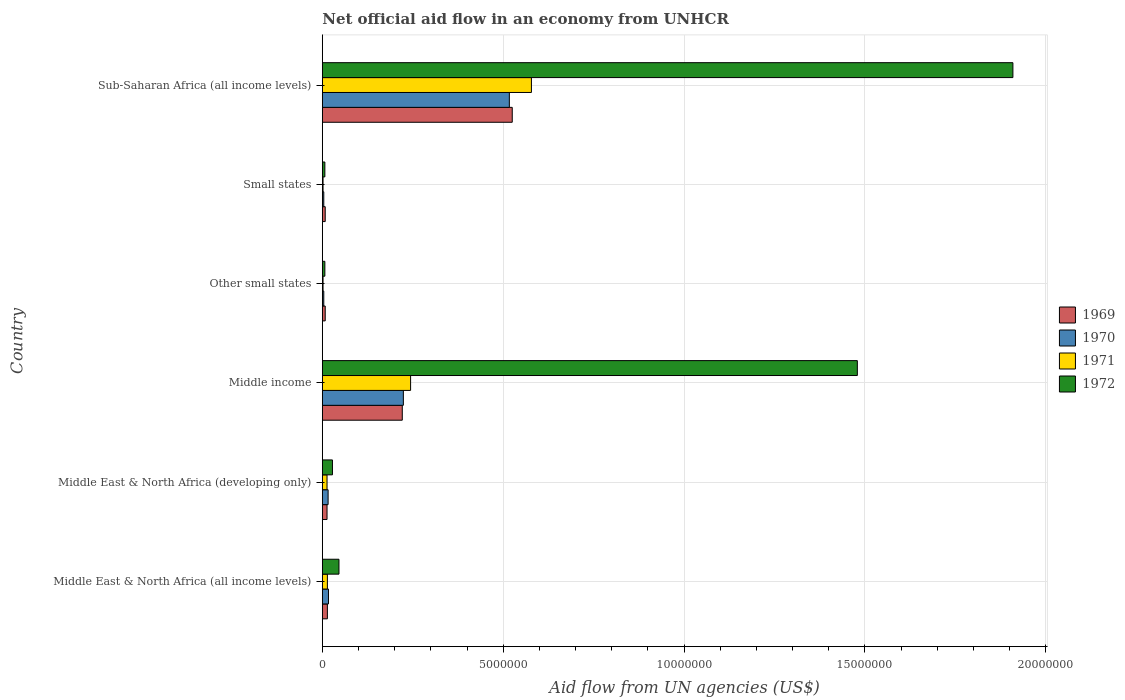How many different coloured bars are there?
Offer a very short reply. 4. How many groups of bars are there?
Your answer should be compact. 6. How many bars are there on the 5th tick from the bottom?
Give a very brief answer. 4. What is the label of the 2nd group of bars from the top?
Provide a succinct answer. Small states. In how many cases, is the number of bars for a given country not equal to the number of legend labels?
Keep it short and to the point. 0. What is the net official aid flow in 1971 in Middle East & North Africa (all income levels)?
Give a very brief answer. 1.40e+05. Across all countries, what is the maximum net official aid flow in 1970?
Make the answer very short. 5.17e+06. Across all countries, what is the minimum net official aid flow in 1970?
Keep it short and to the point. 4.00e+04. In which country was the net official aid flow in 1971 maximum?
Ensure brevity in your answer.  Sub-Saharan Africa (all income levels). In which country was the net official aid flow in 1969 minimum?
Provide a short and direct response. Other small states. What is the total net official aid flow in 1972 in the graph?
Give a very brief answer. 3.48e+07. What is the difference between the net official aid flow in 1972 in Other small states and the net official aid flow in 1971 in Middle East & North Africa (developing only)?
Provide a succinct answer. -6.00e+04. What is the average net official aid flow in 1972 per country?
Offer a terse response. 5.79e+06. In how many countries, is the net official aid flow in 1972 greater than 14000000 US$?
Make the answer very short. 2. What is the ratio of the net official aid flow in 1970 in Middle East & North Africa (developing only) to that in Sub-Saharan Africa (all income levels)?
Make the answer very short. 0.03. Is the difference between the net official aid flow in 1969 in Middle East & North Africa (developing only) and Small states greater than the difference between the net official aid flow in 1970 in Middle East & North Africa (developing only) and Small states?
Provide a succinct answer. No. What is the difference between the highest and the second highest net official aid flow in 1969?
Keep it short and to the point. 3.04e+06. What is the difference between the highest and the lowest net official aid flow in 1969?
Offer a terse response. 5.17e+06. In how many countries, is the net official aid flow in 1969 greater than the average net official aid flow in 1969 taken over all countries?
Your answer should be very brief. 2. Is it the case that in every country, the sum of the net official aid flow in 1972 and net official aid flow in 1969 is greater than the sum of net official aid flow in 1970 and net official aid flow in 1971?
Give a very brief answer. No. What does the 4th bar from the bottom in Small states represents?
Provide a short and direct response. 1972. Is it the case that in every country, the sum of the net official aid flow in 1970 and net official aid flow in 1969 is greater than the net official aid flow in 1972?
Your answer should be very brief. No. How many bars are there?
Your answer should be compact. 24. Are all the bars in the graph horizontal?
Your answer should be very brief. Yes. How many countries are there in the graph?
Offer a very short reply. 6. What is the difference between two consecutive major ticks on the X-axis?
Make the answer very short. 5.00e+06. Are the values on the major ticks of X-axis written in scientific E-notation?
Keep it short and to the point. No. Does the graph contain any zero values?
Give a very brief answer. No. Does the graph contain grids?
Your answer should be very brief. Yes. What is the title of the graph?
Make the answer very short. Net official aid flow in an economy from UNHCR. What is the label or title of the X-axis?
Your response must be concise. Aid flow from UN agencies (US$). What is the Aid flow from UN agencies (US$) of 1969 in Middle East & North Africa (all income levels)?
Keep it short and to the point. 1.40e+05. What is the Aid flow from UN agencies (US$) of 1970 in Middle East & North Africa (all income levels)?
Provide a short and direct response. 1.70e+05. What is the Aid flow from UN agencies (US$) of 1969 in Middle East & North Africa (developing only)?
Provide a succinct answer. 1.30e+05. What is the Aid flow from UN agencies (US$) of 1971 in Middle East & North Africa (developing only)?
Your response must be concise. 1.30e+05. What is the Aid flow from UN agencies (US$) in 1972 in Middle East & North Africa (developing only)?
Give a very brief answer. 2.80e+05. What is the Aid flow from UN agencies (US$) in 1969 in Middle income?
Keep it short and to the point. 2.21e+06. What is the Aid flow from UN agencies (US$) of 1970 in Middle income?
Your answer should be very brief. 2.24e+06. What is the Aid flow from UN agencies (US$) of 1971 in Middle income?
Make the answer very short. 2.44e+06. What is the Aid flow from UN agencies (US$) of 1972 in Middle income?
Ensure brevity in your answer.  1.48e+07. What is the Aid flow from UN agencies (US$) in 1969 in Other small states?
Ensure brevity in your answer.  8.00e+04. What is the Aid flow from UN agencies (US$) of 1970 in Small states?
Offer a very short reply. 4.00e+04. What is the Aid flow from UN agencies (US$) of 1971 in Small states?
Provide a short and direct response. 2.00e+04. What is the Aid flow from UN agencies (US$) of 1969 in Sub-Saharan Africa (all income levels)?
Your answer should be compact. 5.25e+06. What is the Aid flow from UN agencies (US$) in 1970 in Sub-Saharan Africa (all income levels)?
Your answer should be very brief. 5.17e+06. What is the Aid flow from UN agencies (US$) of 1971 in Sub-Saharan Africa (all income levels)?
Provide a succinct answer. 5.78e+06. What is the Aid flow from UN agencies (US$) of 1972 in Sub-Saharan Africa (all income levels)?
Your answer should be very brief. 1.91e+07. Across all countries, what is the maximum Aid flow from UN agencies (US$) in 1969?
Ensure brevity in your answer.  5.25e+06. Across all countries, what is the maximum Aid flow from UN agencies (US$) in 1970?
Ensure brevity in your answer.  5.17e+06. Across all countries, what is the maximum Aid flow from UN agencies (US$) in 1971?
Make the answer very short. 5.78e+06. Across all countries, what is the maximum Aid flow from UN agencies (US$) of 1972?
Provide a short and direct response. 1.91e+07. Across all countries, what is the minimum Aid flow from UN agencies (US$) of 1969?
Keep it short and to the point. 8.00e+04. Across all countries, what is the minimum Aid flow from UN agencies (US$) in 1972?
Keep it short and to the point. 7.00e+04. What is the total Aid flow from UN agencies (US$) of 1969 in the graph?
Offer a very short reply. 7.89e+06. What is the total Aid flow from UN agencies (US$) of 1970 in the graph?
Offer a terse response. 7.82e+06. What is the total Aid flow from UN agencies (US$) of 1971 in the graph?
Ensure brevity in your answer.  8.53e+06. What is the total Aid flow from UN agencies (US$) of 1972 in the graph?
Offer a very short reply. 3.48e+07. What is the difference between the Aid flow from UN agencies (US$) of 1969 in Middle East & North Africa (all income levels) and that in Middle East & North Africa (developing only)?
Give a very brief answer. 10000. What is the difference between the Aid flow from UN agencies (US$) of 1972 in Middle East & North Africa (all income levels) and that in Middle East & North Africa (developing only)?
Ensure brevity in your answer.  1.80e+05. What is the difference between the Aid flow from UN agencies (US$) in 1969 in Middle East & North Africa (all income levels) and that in Middle income?
Give a very brief answer. -2.07e+06. What is the difference between the Aid flow from UN agencies (US$) of 1970 in Middle East & North Africa (all income levels) and that in Middle income?
Offer a very short reply. -2.07e+06. What is the difference between the Aid flow from UN agencies (US$) in 1971 in Middle East & North Africa (all income levels) and that in Middle income?
Give a very brief answer. -2.30e+06. What is the difference between the Aid flow from UN agencies (US$) in 1972 in Middle East & North Africa (all income levels) and that in Middle income?
Ensure brevity in your answer.  -1.43e+07. What is the difference between the Aid flow from UN agencies (US$) in 1969 in Middle East & North Africa (all income levels) and that in Other small states?
Your answer should be compact. 6.00e+04. What is the difference between the Aid flow from UN agencies (US$) in 1970 in Middle East & North Africa (all income levels) and that in Small states?
Keep it short and to the point. 1.30e+05. What is the difference between the Aid flow from UN agencies (US$) in 1971 in Middle East & North Africa (all income levels) and that in Small states?
Your answer should be compact. 1.20e+05. What is the difference between the Aid flow from UN agencies (US$) in 1969 in Middle East & North Africa (all income levels) and that in Sub-Saharan Africa (all income levels)?
Ensure brevity in your answer.  -5.11e+06. What is the difference between the Aid flow from UN agencies (US$) of 1970 in Middle East & North Africa (all income levels) and that in Sub-Saharan Africa (all income levels)?
Provide a succinct answer. -5.00e+06. What is the difference between the Aid flow from UN agencies (US$) of 1971 in Middle East & North Africa (all income levels) and that in Sub-Saharan Africa (all income levels)?
Give a very brief answer. -5.64e+06. What is the difference between the Aid flow from UN agencies (US$) of 1972 in Middle East & North Africa (all income levels) and that in Sub-Saharan Africa (all income levels)?
Ensure brevity in your answer.  -1.86e+07. What is the difference between the Aid flow from UN agencies (US$) of 1969 in Middle East & North Africa (developing only) and that in Middle income?
Keep it short and to the point. -2.08e+06. What is the difference between the Aid flow from UN agencies (US$) of 1970 in Middle East & North Africa (developing only) and that in Middle income?
Your answer should be compact. -2.08e+06. What is the difference between the Aid flow from UN agencies (US$) in 1971 in Middle East & North Africa (developing only) and that in Middle income?
Your response must be concise. -2.31e+06. What is the difference between the Aid flow from UN agencies (US$) in 1972 in Middle East & North Africa (developing only) and that in Middle income?
Offer a terse response. -1.45e+07. What is the difference between the Aid flow from UN agencies (US$) in 1969 in Middle East & North Africa (developing only) and that in Other small states?
Give a very brief answer. 5.00e+04. What is the difference between the Aid flow from UN agencies (US$) of 1971 in Middle East & North Africa (developing only) and that in Other small states?
Your response must be concise. 1.10e+05. What is the difference between the Aid flow from UN agencies (US$) in 1972 in Middle East & North Africa (developing only) and that in Other small states?
Make the answer very short. 2.10e+05. What is the difference between the Aid flow from UN agencies (US$) of 1969 in Middle East & North Africa (developing only) and that in Sub-Saharan Africa (all income levels)?
Provide a succinct answer. -5.12e+06. What is the difference between the Aid flow from UN agencies (US$) of 1970 in Middle East & North Africa (developing only) and that in Sub-Saharan Africa (all income levels)?
Ensure brevity in your answer.  -5.01e+06. What is the difference between the Aid flow from UN agencies (US$) of 1971 in Middle East & North Africa (developing only) and that in Sub-Saharan Africa (all income levels)?
Provide a short and direct response. -5.65e+06. What is the difference between the Aid flow from UN agencies (US$) in 1972 in Middle East & North Africa (developing only) and that in Sub-Saharan Africa (all income levels)?
Your answer should be very brief. -1.88e+07. What is the difference between the Aid flow from UN agencies (US$) in 1969 in Middle income and that in Other small states?
Your answer should be compact. 2.13e+06. What is the difference between the Aid flow from UN agencies (US$) in 1970 in Middle income and that in Other small states?
Your response must be concise. 2.20e+06. What is the difference between the Aid flow from UN agencies (US$) of 1971 in Middle income and that in Other small states?
Your answer should be very brief. 2.42e+06. What is the difference between the Aid flow from UN agencies (US$) in 1972 in Middle income and that in Other small states?
Your answer should be very brief. 1.47e+07. What is the difference between the Aid flow from UN agencies (US$) in 1969 in Middle income and that in Small states?
Your answer should be compact. 2.13e+06. What is the difference between the Aid flow from UN agencies (US$) of 1970 in Middle income and that in Small states?
Make the answer very short. 2.20e+06. What is the difference between the Aid flow from UN agencies (US$) of 1971 in Middle income and that in Small states?
Give a very brief answer. 2.42e+06. What is the difference between the Aid flow from UN agencies (US$) in 1972 in Middle income and that in Small states?
Your answer should be very brief. 1.47e+07. What is the difference between the Aid flow from UN agencies (US$) in 1969 in Middle income and that in Sub-Saharan Africa (all income levels)?
Keep it short and to the point. -3.04e+06. What is the difference between the Aid flow from UN agencies (US$) of 1970 in Middle income and that in Sub-Saharan Africa (all income levels)?
Make the answer very short. -2.93e+06. What is the difference between the Aid flow from UN agencies (US$) in 1971 in Middle income and that in Sub-Saharan Africa (all income levels)?
Provide a succinct answer. -3.34e+06. What is the difference between the Aid flow from UN agencies (US$) of 1972 in Middle income and that in Sub-Saharan Africa (all income levels)?
Ensure brevity in your answer.  -4.30e+06. What is the difference between the Aid flow from UN agencies (US$) of 1971 in Other small states and that in Small states?
Offer a very short reply. 0. What is the difference between the Aid flow from UN agencies (US$) of 1972 in Other small states and that in Small states?
Offer a terse response. 0. What is the difference between the Aid flow from UN agencies (US$) of 1969 in Other small states and that in Sub-Saharan Africa (all income levels)?
Provide a succinct answer. -5.17e+06. What is the difference between the Aid flow from UN agencies (US$) of 1970 in Other small states and that in Sub-Saharan Africa (all income levels)?
Ensure brevity in your answer.  -5.13e+06. What is the difference between the Aid flow from UN agencies (US$) in 1971 in Other small states and that in Sub-Saharan Africa (all income levels)?
Keep it short and to the point. -5.76e+06. What is the difference between the Aid flow from UN agencies (US$) of 1972 in Other small states and that in Sub-Saharan Africa (all income levels)?
Make the answer very short. -1.90e+07. What is the difference between the Aid flow from UN agencies (US$) in 1969 in Small states and that in Sub-Saharan Africa (all income levels)?
Keep it short and to the point. -5.17e+06. What is the difference between the Aid flow from UN agencies (US$) in 1970 in Small states and that in Sub-Saharan Africa (all income levels)?
Your response must be concise. -5.13e+06. What is the difference between the Aid flow from UN agencies (US$) of 1971 in Small states and that in Sub-Saharan Africa (all income levels)?
Your response must be concise. -5.76e+06. What is the difference between the Aid flow from UN agencies (US$) in 1972 in Small states and that in Sub-Saharan Africa (all income levels)?
Provide a succinct answer. -1.90e+07. What is the difference between the Aid flow from UN agencies (US$) in 1969 in Middle East & North Africa (all income levels) and the Aid flow from UN agencies (US$) in 1971 in Middle East & North Africa (developing only)?
Offer a terse response. 10000. What is the difference between the Aid flow from UN agencies (US$) in 1970 in Middle East & North Africa (all income levels) and the Aid flow from UN agencies (US$) in 1972 in Middle East & North Africa (developing only)?
Keep it short and to the point. -1.10e+05. What is the difference between the Aid flow from UN agencies (US$) of 1971 in Middle East & North Africa (all income levels) and the Aid flow from UN agencies (US$) of 1972 in Middle East & North Africa (developing only)?
Keep it short and to the point. -1.40e+05. What is the difference between the Aid flow from UN agencies (US$) in 1969 in Middle East & North Africa (all income levels) and the Aid flow from UN agencies (US$) in 1970 in Middle income?
Your answer should be very brief. -2.10e+06. What is the difference between the Aid flow from UN agencies (US$) in 1969 in Middle East & North Africa (all income levels) and the Aid flow from UN agencies (US$) in 1971 in Middle income?
Your answer should be very brief. -2.30e+06. What is the difference between the Aid flow from UN agencies (US$) in 1969 in Middle East & North Africa (all income levels) and the Aid flow from UN agencies (US$) in 1972 in Middle income?
Offer a terse response. -1.46e+07. What is the difference between the Aid flow from UN agencies (US$) in 1970 in Middle East & North Africa (all income levels) and the Aid flow from UN agencies (US$) in 1971 in Middle income?
Your answer should be very brief. -2.27e+06. What is the difference between the Aid flow from UN agencies (US$) in 1970 in Middle East & North Africa (all income levels) and the Aid flow from UN agencies (US$) in 1972 in Middle income?
Make the answer very short. -1.46e+07. What is the difference between the Aid flow from UN agencies (US$) of 1971 in Middle East & North Africa (all income levels) and the Aid flow from UN agencies (US$) of 1972 in Middle income?
Provide a short and direct response. -1.46e+07. What is the difference between the Aid flow from UN agencies (US$) in 1969 in Middle East & North Africa (all income levels) and the Aid flow from UN agencies (US$) in 1970 in Other small states?
Provide a succinct answer. 1.00e+05. What is the difference between the Aid flow from UN agencies (US$) in 1969 in Middle East & North Africa (all income levels) and the Aid flow from UN agencies (US$) in 1972 in Other small states?
Provide a succinct answer. 7.00e+04. What is the difference between the Aid flow from UN agencies (US$) in 1970 in Middle East & North Africa (all income levels) and the Aid flow from UN agencies (US$) in 1971 in Other small states?
Provide a short and direct response. 1.50e+05. What is the difference between the Aid flow from UN agencies (US$) of 1970 in Middle East & North Africa (all income levels) and the Aid flow from UN agencies (US$) of 1972 in Other small states?
Give a very brief answer. 1.00e+05. What is the difference between the Aid flow from UN agencies (US$) in 1971 in Middle East & North Africa (all income levels) and the Aid flow from UN agencies (US$) in 1972 in Other small states?
Give a very brief answer. 7.00e+04. What is the difference between the Aid flow from UN agencies (US$) in 1969 in Middle East & North Africa (all income levels) and the Aid flow from UN agencies (US$) in 1970 in Small states?
Keep it short and to the point. 1.00e+05. What is the difference between the Aid flow from UN agencies (US$) of 1969 in Middle East & North Africa (all income levels) and the Aid flow from UN agencies (US$) of 1971 in Small states?
Provide a succinct answer. 1.20e+05. What is the difference between the Aid flow from UN agencies (US$) in 1969 in Middle East & North Africa (all income levels) and the Aid flow from UN agencies (US$) in 1972 in Small states?
Ensure brevity in your answer.  7.00e+04. What is the difference between the Aid flow from UN agencies (US$) of 1969 in Middle East & North Africa (all income levels) and the Aid flow from UN agencies (US$) of 1970 in Sub-Saharan Africa (all income levels)?
Give a very brief answer. -5.03e+06. What is the difference between the Aid flow from UN agencies (US$) of 1969 in Middle East & North Africa (all income levels) and the Aid flow from UN agencies (US$) of 1971 in Sub-Saharan Africa (all income levels)?
Your response must be concise. -5.64e+06. What is the difference between the Aid flow from UN agencies (US$) in 1969 in Middle East & North Africa (all income levels) and the Aid flow from UN agencies (US$) in 1972 in Sub-Saharan Africa (all income levels)?
Provide a short and direct response. -1.90e+07. What is the difference between the Aid flow from UN agencies (US$) in 1970 in Middle East & North Africa (all income levels) and the Aid flow from UN agencies (US$) in 1971 in Sub-Saharan Africa (all income levels)?
Provide a succinct answer. -5.61e+06. What is the difference between the Aid flow from UN agencies (US$) in 1970 in Middle East & North Africa (all income levels) and the Aid flow from UN agencies (US$) in 1972 in Sub-Saharan Africa (all income levels)?
Give a very brief answer. -1.89e+07. What is the difference between the Aid flow from UN agencies (US$) in 1971 in Middle East & North Africa (all income levels) and the Aid flow from UN agencies (US$) in 1972 in Sub-Saharan Africa (all income levels)?
Your response must be concise. -1.90e+07. What is the difference between the Aid flow from UN agencies (US$) in 1969 in Middle East & North Africa (developing only) and the Aid flow from UN agencies (US$) in 1970 in Middle income?
Your answer should be very brief. -2.11e+06. What is the difference between the Aid flow from UN agencies (US$) of 1969 in Middle East & North Africa (developing only) and the Aid flow from UN agencies (US$) of 1971 in Middle income?
Keep it short and to the point. -2.31e+06. What is the difference between the Aid flow from UN agencies (US$) in 1969 in Middle East & North Africa (developing only) and the Aid flow from UN agencies (US$) in 1972 in Middle income?
Keep it short and to the point. -1.47e+07. What is the difference between the Aid flow from UN agencies (US$) in 1970 in Middle East & North Africa (developing only) and the Aid flow from UN agencies (US$) in 1971 in Middle income?
Give a very brief answer. -2.28e+06. What is the difference between the Aid flow from UN agencies (US$) in 1970 in Middle East & North Africa (developing only) and the Aid flow from UN agencies (US$) in 1972 in Middle income?
Your answer should be very brief. -1.46e+07. What is the difference between the Aid flow from UN agencies (US$) in 1971 in Middle East & North Africa (developing only) and the Aid flow from UN agencies (US$) in 1972 in Middle income?
Provide a succinct answer. -1.47e+07. What is the difference between the Aid flow from UN agencies (US$) of 1969 in Middle East & North Africa (developing only) and the Aid flow from UN agencies (US$) of 1970 in Other small states?
Your answer should be compact. 9.00e+04. What is the difference between the Aid flow from UN agencies (US$) in 1969 in Middle East & North Africa (developing only) and the Aid flow from UN agencies (US$) in 1972 in Other small states?
Your answer should be compact. 6.00e+04. What is the difference between the Aid flow from UN agencies (US$) in 1970 in Middle East & North Africa (developing only) and the Aid flow from UN agencies (US$) in 1971 in Other small states?
Offer a terse response. 1.40e+05. What is the difference between the Aid flow from UN agencies (US$) of 1970 in Middle East & North Africa (developing only) and the Aid flow from UN agencies (US$) of 1972 in Other small states?
Your answer should be very brief. 9.00e+04. What is the difference between the Aid flow from UN agencies (US$) in 1971 in Middle East & North Africa (developing only) and the Aid flow from UN agencies (US$) in 1972 in Other small states?
Give a very brief answer. 6.00e+04. What is the difference between the Aid flow from UN agencies (US$) in 1969 in Middle East & North Africa (developing only) and the Aid flow from UN agencies (US$) in 1970 in Small states?
Ensure brevity in your answer.  9.00e+04. What is the difference between the Aid flow from UN agencies (US$) of 1969 in Middle East & North Africa (developing only) and the Aid flow from UN agencies (US$) of 1971 in Small states?
Offer a very short reply. 1.10e+05. What is the difference between the Aid flow from UN agencies (US$) in 1970 in Middle East & North Africa (developing only) and the Aid flow from UN agencies (US$) in 1972 in Small states?
Provide a succinct answer. 9.00e+04. What is the difference between the Aid flow from UN agencies (US$) of 1969 in Middle East & North Africa (developing only) and the Aid flow from UN agencies (US$) of 1970 in Sub-Saharan Africa (all income levels)?
Your answer should be compact. -5.04e+06. What is the difference between the Aid flow from UN agencies (US$) in 1969 in Middle East & North Africa (developing only) and the Aid flow from UN agencies (US$) in 1971 in Sub-Saharan Africa (all income levels)?
Offer a terse response. -5.65e+06. What is the difference between the Aid flow from UN agencies (US$) of 1969 in Middle East & North Africa (developing only) and the Aid flow from UN agencies (US$) of 1972 in Sub-Saharan Africa (all income levels)?
Your answer should be very brief. -1.90e+07. What is the difference between the Aid flow from UN agencies (US$) of 1970 in Middle East & North Africa (developing only) and the Aid flow from UN agencies (US$) of 1971 in Sub-Saharan Africa (all income levels)?
Offer a terse response. -5.62e+06. What is the difference between the Aid flow from UN agencies (US$) of 1970 in Middle East & North Africa (developing only) and the Aid flow from UN agencies (US$) of 1972 in Sub-Saharan Africa (all income levels)?
Provide a short and direct response. -1.89e+07. What is the difference between the Aid flow from UN agencies (US$) in 1971 in Middle East & North Africa (developing only) and the Aid flow from UN agencies (US$) in 1972 in Sub-Saharan Africa (all income levels)?
Keep it short and to the point. -1.90e+07. What is the difference between the Aid flow from UN agencies (US$) of 1969 in Middle income and the Aid flow from UN agencies (US$) of 1970 in Other small states?
Provide a succinct answer. 2.17e+06. What is the difference between the Aid flow from UN agencies (US$) of 1969 in Middle income and the Aid flow from UN agencies (US$) of 1971 in Other small states?
Give a very brief answer. 2.19e+06. What is the difference between the Aid flow from UN agencies (US$) of 1969 in Middle income and the Aid flow from UN agencies (US$) of 1972 in Other small states?
Provide a short and direct response. 2.14e+06. What is the difference between the Aid flow from UN agencies (US$) in 1970 in Middle income and the Aid flow from UN agencies (US$) in 1971 in Other small states?
Make the answer very short. 2.22e+06. What is the difference between the Aid flow from UN agencies (US$) of 1970 in Middle income and the Aid flow from UN agencies (US$) of 1972 in Other small states?
Your answer should be very brief. 2.17e+06. What is the difference between the Aid flow from UN agencies (US$) of 1971 in Middle income and the Aid flow from UN agencies (US$) of 1972 in Other small states?
Keep it short and to the point. 2.37e+06. What is the difference between the Aid flow from UN agencies (US$) in 1969 in Middle income and the Aid flow from UN agencies (US$) in 1970 in Small states?
Your response must be concise. 2.17e+06. What is the difference between the Aid flow from UN agencies (US$) of 1969 in Middle income and the Aid flow from UN agencies (US$) of 1971 in Small states?
Give a very brief answer. 2.19e+06. What is the difference between the Aid flow from UN agencies (US$) in 1969 in Middle income and the Aid flow from UN agencies (US$) in 1972 in Small states?
Make the answer very short. 2.14e+06. What is the difference between the Aid flow from UN agencies (US$) in 1970 in Middle income and the Aid flow from UN agencies (US$) in 1971 in Small states?
Provide a succinct answer. 2.22e+06. What is the difference between the Aid flow from UN agencies (US$) of 1970 in Middle income and the Aid flow from UN agencies (US$) of 1972 in Small states?
Provide a short and direct response. 2.17e+06. What is the difference between the Aid flow from UN agencies (US$) of 1971 in Middle income and the Aid flow from UN agencies (US$) of 1972 in Small states?
Make the answer very short. 2.37e+06. What is the difference between the Aid flow from UN agencies (US$) of 1969 in Middle income and the Aid flow from UN agencies (US$) of 1970 in Sub-Saharan Africa (all income levels)?
Keep it short and to the point. -2.96e+06. What is the difference between the Aid flow from UN agencies (US$) of 1969 in Middle income and the Aid flow from UN agencies (US$) of 1971 in Sub-Saharan Africa (all income levels)?
Make the answer very short. -3.57e+06. What is the difference between the Aid flow from UN agencies (US$) in 1969 in Middle income and the Aid flow from UN agencies (US$) in 1972 in Sub-Saharan Africa (all income levels)?
Give a very brief answer. -1.69e+07. What is the difference between the Aid flow from UN agencies (US$) of 1970 in Middle income and the Aid flow from UN agencies (US$) of 1971 in Sub-Saharan Africa (all income levels)?
Provide a short and direct response. -3.54e+06. What is the difference between the Aid flow from UN agencies (US$) in 1970 in Middle income and the Aid flow from UN agencies (US$) in 1972 in Sub-Saharan Africa (all income levels)?
Ensure brevity in your answer.  -1.68e+07. What is the difference between the Aid flow from UN agencies (US$) in 1971 in Middle income and the Aid flow from UN agencies (US$) in 1972 in Sub-Saharan Africa (all income levels)?
Give a very brief answer. -1.66e+07. What is the difference between the Aid flow from UN agencies (US$) of 1969 in Other small states and the Aid flow from UN agencies (US$) of 1970 in Small states?
Your answer should be very brief. 4.00e+04. What is the difference between the Aid flow from UN agencies (US$) in 1970 in Other small states and the Aid flow from UN agencies (US$) in 1972 in Small states?
Ensure brevity in your answer.  -3.00e+04. What is the difference between the Aid flow from UN agencies (US$) in 1971 in Other small states and the Aid flow from UN agencies (US$) in 1972 in Small states?
Your answer should be compact. -5.00e+04. What is the difference between the Aid flow from UN agencies (US$) in 1969 in Other small states and the Aid flow from UN agencies (US$) in 1970 in Sub-Saharan Africa (all income levels)?
Provide a succinct answer. -5.09e+06. What is the difference between the Aid flow from UN agencies (US$) in 1969 in Other small states and the Aid flow from UN agencies (US$) in 1971 in Sub-Saharan Africa (all income levels)?
Ensure brevity in your answer.  -5.70e+06. What is the difference between the Aid flow from UN agencies (US$) in 1969 in Other small states and the Aid flow from UN agencies (US$) in 1972 in Sub-Saharan Africa (all income levels)?
Provide a succinct answer. -1.90e+07. What is the difference between the Aid flow from UN agencies (US$) of 1970 in Other small states and the Aid flow from UN agencies (US$) of 1971 in Sub-Saharan Africa (all income levels)?
Offer a terse response. -5.74e+06. What is the difference between the Aid flow from UN agencies (US$) in 1970 in Other small states and the Aid flow from UN agencies (US$) in 1972 in Sub-Saharan Africa (all income levels)?
Provide a succinct answer. -1.90e+07. What is the difference between the Aid flow from UN agencies (US$) of 1971 in Other small states and the Aid flow from UN agencies (US$) of 1972 in Sub-Saharan Africa (all income levels)?
Give a very brief answer. -1.91e+07. What is the difference between the Aid flow from UN agencies (US$) of 1969 in Small states and the Aid flow from UN agencies (US$) of 1970 in Sub-Saharan Africa (all income levels)?
Ensure brevity in your answer.  -5.09e+06. What is the difference between the Aid flow from UN agencies (US$) in 1969 in Small states and the Aid flow from UN agencies (US$) in 1971 in Sub-Saharan Africa (all income levels)?
Offer a very short reply. -5.70e+06. What is the difference between the Aid flow from UN agencies (US$) of 1969 in Small states and the Aid flow from UN agencies (US$) of 1972 in Sub-Saharan Africa (all income levels)?
Provide a succinct answer. -1.90e+07. What is the difference between the Aid flow from UN agencies (US$) of 1970 in Small states and the Aid flow from UN agencies (US$) of 1971 in Sub-Saharan Africa (all income levels)?
Give a very brief answer. -5.74e+06. What is the difference between the Aid flow from UN agencies (US$) of 1970 in Small states and the Aid flow from UN agencies (US$) of 1972 in Sub-Saharan Africa (all income levels)?
Give a very brief answer. -1.90e+07. What is the difference between the Aid flow from UN agencies (US$) of 1971 in Small states and the Aid flow from UN agencies (US$) of 1972 in Sub-Saharan Africa (all income levels)?
Your answer should be compact. -1.91e+07. What is the average Aid flow from UN agencies (US$) of 1969 per country?
Your response must be concise. 1.32e+06. What is the average Aid flow from UN agencies (US$) in 1970 per country?
Your answer should be very brief. 1.30e+06. What is the average Aid flow from UN agencies (US$) in 1971 per country?
Make the answer very short. 1.42e+06. What is the average Aid flow from UN agencies (US$) in 1972 per country?
Offer a terse response. 5.79e+06. What is the difference between the Aid flow from UN agencies (US$) in 1969 and Aid flow from UN agencies (US$) in 1970 in Middle East & North Africa (all income levels)?
Make the answer very short. -3.00e+04. What is the difference between the Aid flow from UN agencies (US$) of 1969 and Aid flow from UN agencies (US$) of 1972 in Middle East & North Africa (all income levels)?
Give a very brief answer. -3.20e+05. What is the difference between the Aid flow from UN agencies (US$) of 1970 and Aid flow from UN agencies (US$) of 1972 in Middle East & North Africa (all income levels)?
Offer a very short reply. -2.90e+05. What is the difference between the Aid flow from UN agencies (US$) of 1971 and Aid flow from UN agencies (US$) of 1972 in Middle East & North Africa (all income levels)?
Your answer should be compact. -3.20e+05. What is the difference between the Aid flow from UN agencies (US$) of 1969 and Aid flow from UN agencies (US$) of 1970 in Middle East & North Africa (developing only)?
Your response must be concise. -3.00e+04. What is the difference between the Aid flow from UN agencies (US$) in 1969 and Aid flow from UN agencies (US$) in 1972 in Middle East & North Africa (developing only)?
Your answer should be very brief. -1.50e+05. What is the difference between the Aid flow from UN agencies (US$) in 1970 and Aid flow from UN agencies (US$) in 1971 in Middle East & North Africa (developing only)?
Keep it short and to the point. 3.00e+04. What is the difference between the Aid flow from UN agencies (US$) of 1971 and Aid flow from UN agencies (US$) of 1972 in Middle East & North Africa (developing only)?
Keep it short and to the point. -1.50e+05. What is the difference between the Aid flow from UN agencies (US$) of 1969 and Aid flow from UN agencies (US$) of 1970 in Middle income?
Provide a succinct answer. -3.00e+04. What is the difference between the Aid flow from UN agencies (US$) in 1969 and Aid flow from UN agencies (US$) in 1972 in Middle income?
Offer a terse response. -1.26e+07. What is the difference between the Aid flow from UN agencies (US$) of 1970 and Aid flow from UN agencies (US$) of 1971 in Middle income?
Ensure brevity in your answer.  -2.00e+05. What is the difference between the Aid flow from UN agencies (US$) in 1970 and Aid flow from UN agencies (US$) in 1972 in Middle income?
Keep it short and to the point. -1.26e+07. What is the difference between the Aid flow from UN agencies (US$) of 1971 and Aid flow from UN agencies (US$) of 1972 in Middle income?
Your response must be concise. -1.24e+07. What is the difference between the Aid flow from UN agencies (US$) of 1970 and Aid flow from UN agencies (US$) of 1972 in Other small states?
Your response must be concise. -3.00e+04. What is the difference between the Aid flow from UN agencies (US$) of 1969 and Aid flow from UN agencies (US$) of 1970 in Small states?
Provide a short and direct response. 4.00e+04. What is the difference between the Aid flow from UN agencies (US$) of 1969 and Aid flow from UN agencies (US$) of 1972 in Small states?
Your answer should be very brief. 10000. What is the difference between the Aid flow from UN agencies (US$) in 1970 and Aid flow from UN agencies (US$) in 1972 in Small states?
Your response must be concise. -3.00e+04. What is the difference between the Aid flow from UN agencies (US$) in 1971 and Aid flow from UN agencies (US$) in 1972 in Small states?
Provide a succinct answer. -5.00e+04. What is the difference between the Aid flow from UN agencies (US$) of 1969 and Aid flow from UN agencies (US$) of 1971 in Sub-Saharan Africa (all income levels)?
Make the answer very short. -5.30e+05. What is the difference between the Aid flow from UN agencies (US$) in 1969 and Aid flow from UN agencies (US$) in 1972 in Sub-Saharan Africa (all income levels)?
Make the answer very short. -1.38e+07. What is the difference between the Aid flow from UN agencies (US$) in 1970 and Aid flow from UN agencies (US$) in 1971 in Sub-Saharan Africa (all income levels)?
Your answer should be very brief. -6.10e+05. What is the difference between the Aid flow from UN agencies (US$) in 1970 and Aid flow from UN agencies (US$) in 1972 in Sub-Saharan Africa (all income levels)?
Ensure brevity in your answer.  -1.39e+07. What is the difference between the Aid flow from UN agencies (US$) of 1971 and Aid flow from UN agencies (US$) of 1972 in Sub-Saharan Africa (all income levels)?
Your answer should be very brief. -1.33e+07. What is the ratio of the Aid flow from UN agencies (US$) of 1971 in Middle East & North Africa (all income levels) to that in Middle East & North Africa (developing only)?
Ensure brevity in your answer.  1.08. What is the ratio of the Aid flow from UN agencies (US$) in 1972 in Middle East & North Africa (all income levels) to that in Middle East & North Africa (developing only)?
Offer a very short reply. 1.64. What is the ratio of the Aid flow from UN agencies (US$) in 1969 in Middle East & North Africa (all income levels) to that in Middle income?
Your answer should be compact. 0.06. What is the ratio of the Aid flow from UN agencies (US$) in 1970 in Middle East & North Africa (all income levels) to that in Middle income?
Provide a short and direct response. 0.08. What is the ratio of the Aid flow from UN agencies (US$) of 1971 in Middle East & North Africa (all income levels) to that in Middle income?
Offer a very short reply. 0.06. What is the ratio of the Aid flow from UN agencies (US$) of 1972 in Middle East & North Africa (all income levels) to that in Middle income?
Provide a short and direct response. 0.03. What is the ratio of the Aid flow from UN agencies (US$) in 1970 in Middle East & North Africa (all income levels) to that in Other small states?
Keep it short and to the point. 4.25. What is the ratio of the Aid flow from UN agencies (US$) in 1971 in Middle East & North Africa (all income levels) to that in Other small states?
Give a very brief answer. 7. What is the ratio of the Aid flow from UN agencies (US$) of 1972 in Middle East & North Africa (all income levels) to that in Other small states?
Offer a very short reply. 6.57. What is the ratio of the Aid flow from UN agencies (US$) of 1969 in Middle East & North Africa (all income levels) to that in Small states?
Provide a succinct answer. 1.75. What is the ratio of the Aid flow from UN agencies (US$) in 1970 in Middle East & North Africa (all income levels) to that in Small states?
Offer a terse response. 4.25. What is the ratio of the Aid flow from UN agencies (US$) in 1971 in Middle East & North Africa (all income levels) to that in Small states?
Ensure brevity in your answer.  7. What is the ratio of the Aid flow from UN agencies (US$) of 1972 in Middle East & North Africa (all income levels) to that in Small states?
Provide a short and direct response. 6.57. What is the ratio of the Aid flow from UN agencies (US$) of 1969 in Middle East & North Africa (all income levels) to that in Sub-Saharan Africa (all income levels)?
Offer a very short reply. 0.03. What is the ratio of the Aid flow from UN agencies (US$) in 1970 in Middle East & North Africa (all income levels) to that in Sub-Saharan Africa (all income levels)?
Ensure brevity in your answer.  0.03. What is the ratio of the Aid flow from UN agencies (US$) in 1971 in Middle East & North Africa (all income levels) to that in Sub-Saharan Africa (all income levels)?
Offer a terse response. 0.02. What is the ratio of the Aid flow from UN agencies (US$) of 1972 in Middle East & North Africa (all income levels) to that in Sub-Saharan Africa (all income levels)?
Ensure brevity in your answer.  0.02. What is the ratio of the Aid flow from UN agencies (US$) of 1969 in Middle East & North Africa (developing only) to that in Middle income?
Make the answer very short. 0.06. What is the ratio of the Aid flow from UN agencies (US$) in 1970 in Middle East & North Africa (developing only) to that in Middle income?
Provide a succinct answer. 0.07. What is the ratio of the Aid flow from UN agencies (US$) in 1971 in Middle East & North Africa (developing only) to that in Middle income?
Provide a succinct answer. 0.05. What is the ratio of the Aid flow from UN agencies (US$) in 1972 in Middle East & North Africa (developing only) to that in Middle income?
Offer a terse response. 0.02. What is the ratio of the Aid flow from UN agencies (US$) of 1969 in Middle East & North Africa (developing only) to that in Other small states?
Provide a succinct answer. 1.62. What is the ratio of the Aid flow from UN agencies (US$) in 1970 in Middle East & North Africa (developing only) to that in Other small states?
Ensure brevity in your answer.  4. What is the ratio of the Aid flow from UN agencies (US$) in 1971 in Middle East & North Africa (developing only) to that in Other small states?
Your answer should be very brief. 6.5. What is the ratio of the Aid flow from UN agencies (US$) of 1972 in Middle East & North Africa (developing only) to that in Other small states?
Your response must be concise. 4. What is the ratio of the Aid flow from UN agencies (US$) in 1969 in Middle East & North Africa (developing only) to that in Small states?
Ensure brevity in your answer.  1.62. What is the ratio of the Aid flow from UN agencies (US$) of 1970 in Middle East & North Africa (developing only) to that in Small states?
Offer a terse response. 4. What is the ratio of the Aid flow from UN agencies (US$) in 1972 in Middle East & North Africa (developing only) to that in Small states?
Give a very brief answer. 4. What is the ratio of the Aid flow from UN agencies (US$) in 1969 in Middle East & North Africa (developing only) to that in Sub-Saharan Africa (all income levels)?
Your answer should be very brief. 0.02. What is the ratio of the Aid flow from UN agencies (US$) in 1970 in Middle East & North Africa (developing only) to that in Sub-Saharan Africa (all income levels)?
Ensure brevity in your answer.  0.03. What is the ratio of the Aid flow from UN agencies (US$) in 1971 in Middle East & North Africa (developing only) to that in Sub-Saharan Africa (all income levels)?
Your answer should be compact. 0.02. What is the ratio of the Aid flow from UN agencies (US$) in 1972 in Middle East & North Africa (developing only) to that in Sub-Saharan Africa (all income levels)?
Offer a very short reply. 0.01. What is the ratio of the Aid flow from UN agencies (US$) in 1969 in Middle income to that in Other small states?
Offer a terse response. 27.62. What is the ratio of the Aid flow from UN agencies (US$) of 1970 in Middle income to that in Other small states?
Offer a terse response. 56. What is the ratio of the Aid flow from UN agencies (US$) in 1971 in Middle income to that in Other small states?
Provide a short and direct response. 122. What is the ratio of the Aid flow from UN agencies (US$) in 1972 in Middle income to that in Other small states?
Your response must be concise. 211.29. What is the ratio of the Aid flow from UN agencies (US$) of 1969 in Middle income to that in Small states?
Offer a very short reply. 27.62. What is the ratio of the Aid flow from UN agencies (US$) of 1970 in Middle income to that in Small states?
Offer a terse response. 56. What is the ratio of the Aid flow from UN agencies (US$) in 1971 in Middle income to that in Small states?
Offer a terse response. 122. What is the ratio of the Aid flow from UN agencies (US$) of 1972 in Middle income to that in Small states?
Give a very brief answer. 211.29. What is the ratio of the Aid flow from UN agencies (US$) in 1969 in Middle income to that in Sub-Saharan Africa (all income levels)?
Give a very brief answer. 0.42. What is the ratio of the Aid flow from UN agencies (US$) of 1970 in Middle income to that in Sub-Saharan Africa (all income levels)?
Your answer should be very brief. 0.43. What is the ratio of the Aid flow from UN agencies (US$) of 1971 in Middle income to that in Sub-Saharan Africa (all income levels)?
Provide a short and direct response. 0.42. What is the ratio of the Aid flow from UN agencies (US$) in 1972 in Middle income to that in Sub-Saharan Africa (all income levels)?
Make the answer very short. 0.77. What is the ratio of the Aid flow from UN agencies (US$) of 1970 in Other small states to that in Small states?
Your answer should be very brief. 1. What is the ratio of the Aid flow from UN agencies (US$) in 1971 in Other small states to that in Small states?
Give a very brief answer. 1. What is the ratio of the Aid flow from UN agencies (US$) in 1972 in Other small states to that in Small states?
Ensure brevity in your answer.  1. What is the ratio of the Aid flow from UN agencies (US$) of 1969 in Other small states to that in Sub-Saharan Africa (all income levels)?
Your answer should be compact. 0.02. What is the ratio of the Aid flow from UN agencies (US$) in 1970 in Other small states to that in Sub-Saharan Africa (all income levels)?
Give a very brief answer. 0.01. What is the ratio of the Aid flow from UN agencies (US$) of 1971 in Other small states to that in Sub-Saharan Africa (all income levels)?
Ensure brevity in your answer.  0. What is the ratio of the Aid flow from UN agencies (US$) of 1972 in Other small states to that in Sub-Saharan Africa (all income levels)?
Provide a short and direct response. 0. What is the ratio of the Aid flow from UN agencies (US$) of 1969 in Small states to that in Sub-Saharan Africa (all income levels)?
Your answer should be compact. 0.02. What is the ratio of the Aid flow from UN agencies (US$) in 1970 in Small states to that in Sub-Saharan Africa (all income levels)?
Keep it short and to the point. 0.01. What is the ratio of the Aid flow from UN agencies (US$) of 1971 in Small states to that in Sub-Saharan Africa (all income levels)?
Your answer should be very brief. 0. What is the ratio of the Aid flow from UN agencies (US$) in 1972 in Small states to that in Sub-Saharan Africa (all income levels)?
Your answer should be compact. 0. What is the difference between the highest and the second highest Aid flow from UN agencies (US$) of 1969?
Offer a very short reply. 3.04e+06. What is the difference between the highest and the second highest Aid flow from UN agencies (US$) in 1970?
Your answer should be compact. 2.93e+06. What is the difference between the highest and the second highest Aid flow from UN agencies (US$) of 1971?
Offer a very short reply. 3.34e+06. What is the difference between the highest and the second highest Aid flow from UN agencies (US$) of 1972?
Your answer should be very brief. 4.30e+06. What is the difference between the highest and the lowest Aid flow from UN agencies (US$) of 1969?
Provide a succinct answer. 5.17e+06. What is the difference between the highest and the lowest Aid flow from UN agencies (US$) of 1970?
Offer a very short reply. 5.13e+06. What is the difference between the highest and the lowest Aid flow from UN agencies (US$) in 1971?
Your response must be concise. 5.76e+06. What is the difference between the highest and the lowest Aid flow from UN agencies (US$) in 1972?
Your response must be concise. 1.90e+07. 